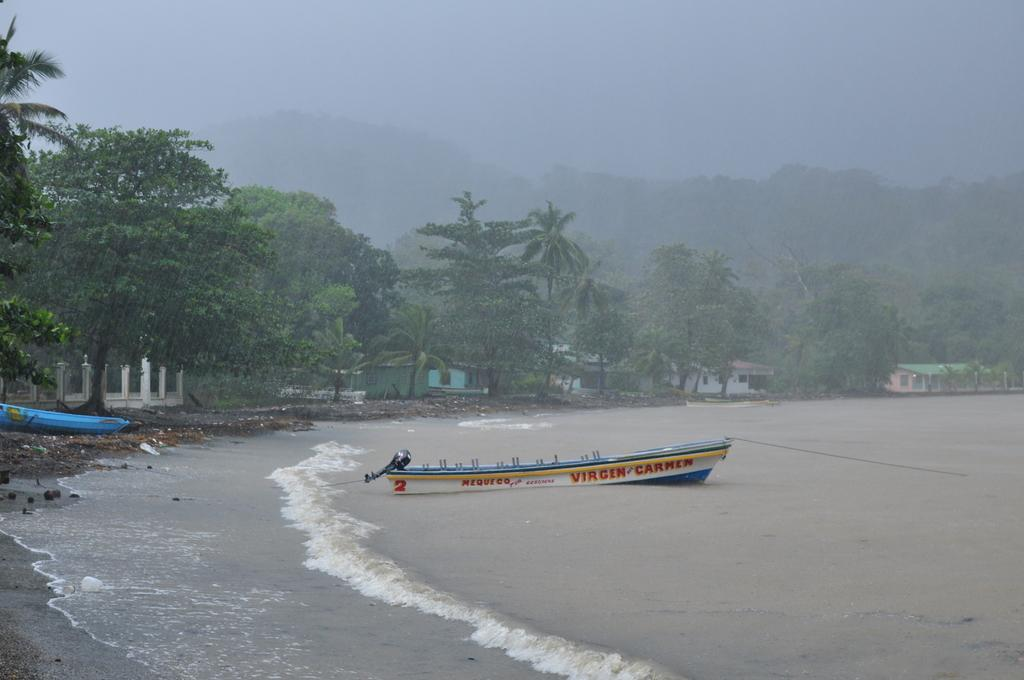What is located above the water in the image? There is a boat above the water in the image. On which side of the image is the boat positioned? The boat is on the left side of the image. What can be seen in the background of the image? There are trees, houses, and the sky visible in the background of the image. What type of car can be seen driving through the water in the image? There is no car present in the image; it features a boat above the water. What act is the rat performing in the image? There is no rat present in the image, so no act can be observed. 